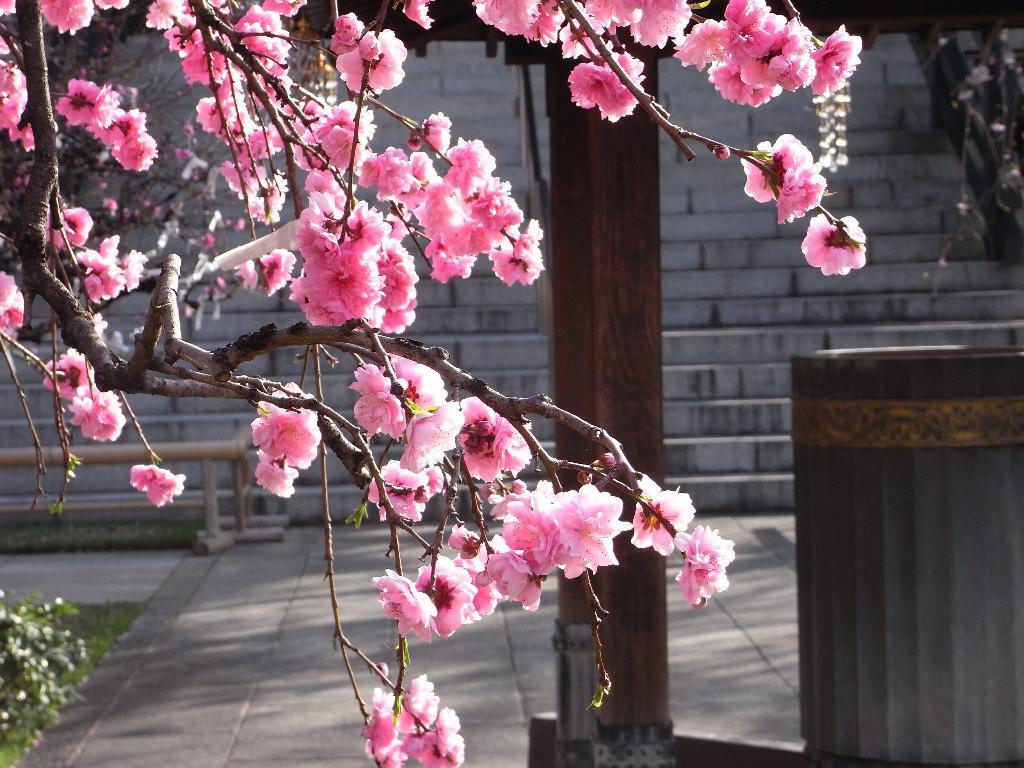In one or two sentences, can you explain what this image depicts? This is a tree with the branches and flowers. These flowers are pink in color. On the right side of the image, I think this is a dustbin. This looks like a wooden pole. These are the stairs. On the left side of the image, I can see the bushes. 